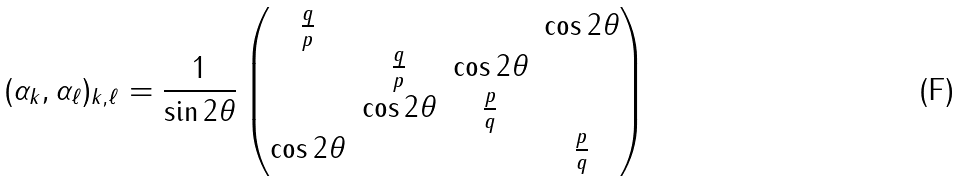<formula> <loc_0><loc_0><loc_500><loc_500>( \alpha _ { k } , \alpha _ { \ell } ) _ { k , \ell } = \frac { 1 } { \sin 2 \theta } \begin{pmatrix} \frac { q } { p } & & & \cos 2 \theta \\ & \frac { q } { p } & \cos 2 \theta \\ & \cos 2 \theta & \frac { p } { q } \\ \cos 2 \theta & & & \frac { p } { q } \end{pmatrix}</formula> 